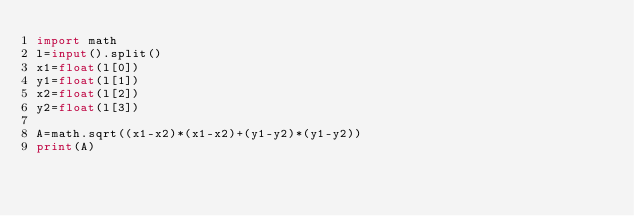Convert code to text. <code><loc_0><loc_0><loc_500><loc_500><_Python_>import math
l=input().split()
x1=float(l[0])
y1=float(l[1])
x2=float(l[2])
y2=float(l[3])

A=math.sqrt((x1-x2)*(x1-x2)+(y1-y2)*(y1-y2))
print(A)
</code> 